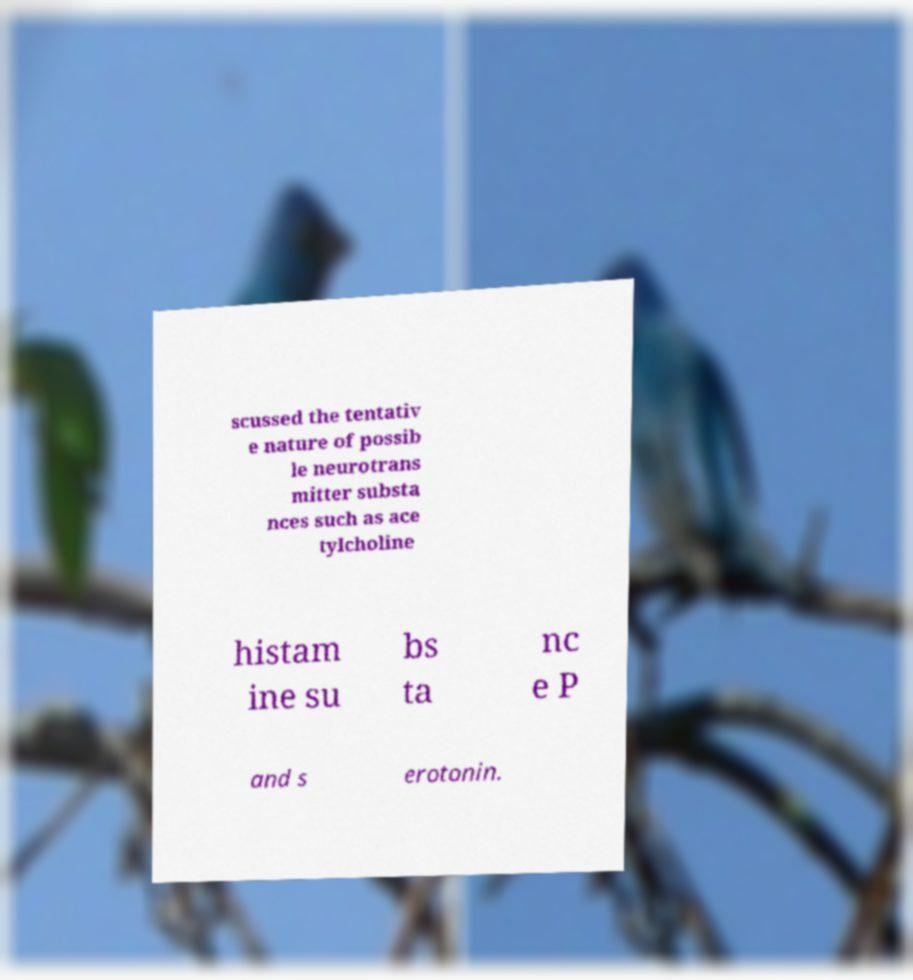Could you assist in decoding the text presented in this image and type it out clearly? scussed the tentativ e nature of possib le neurotrans mitter substa nces such as ace tylcholine histam ine su bs ta nc e P and s erotonin. 